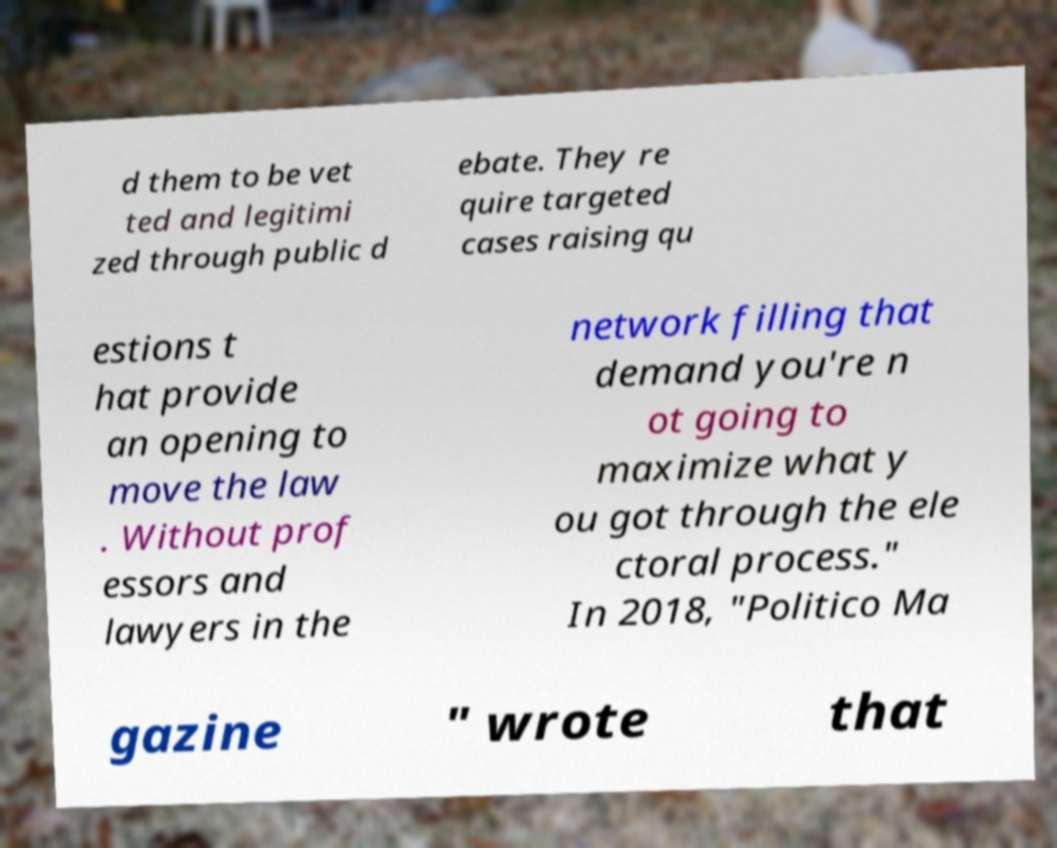Can you read and provide the text displayed in the image?This photo seems to have some interesting text. Can you extract and type it out for me? d them to be vet ted and legitimi zed through public d ebate. They re quire targeted cases raising qu estions t hat provide an opening to move the law . Without prof essors and lawyers in the network filling that demand you're n ot going to maximize what y ou got through the ele ctoral process." In 2018, "Politico Ma gazine " wrote that 